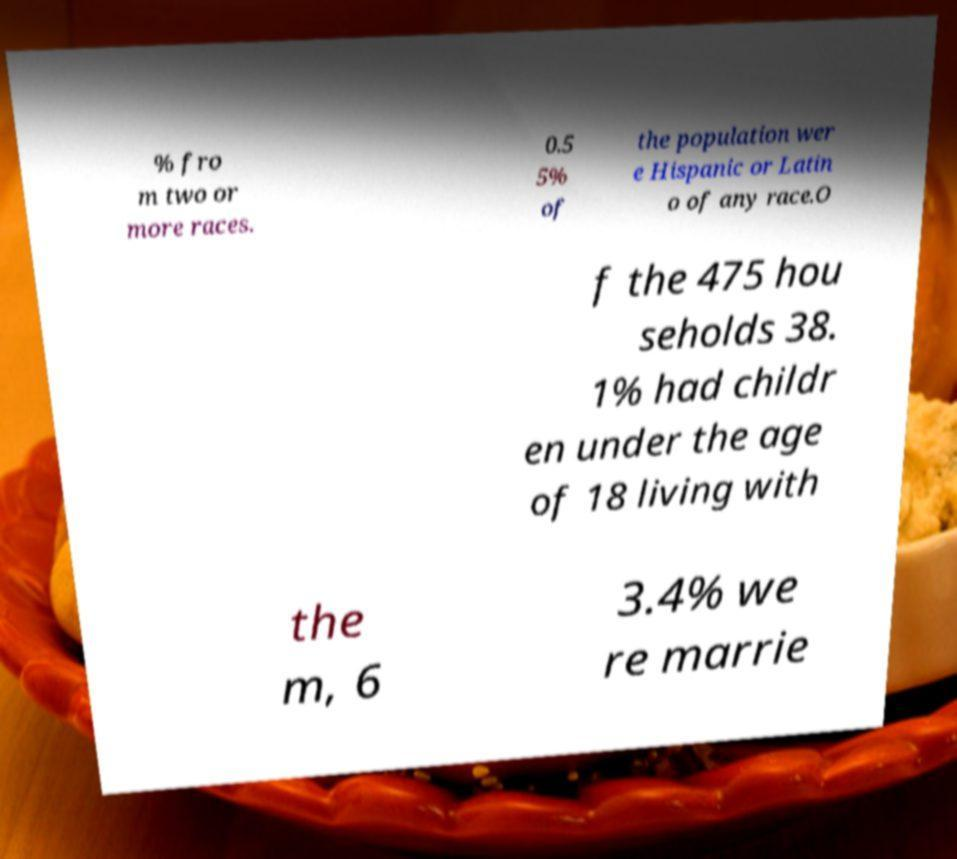Can you read and provide the text displayed in the image?This photo seems to have some interesting text. Can you extract and type it out for me? % fro m two or more races. 0.5 5% of the population wer e Hispanic or Latin o of any race.O f the 475 hou seholds 38. 1% had childr en under the age of 18 living with the m, 6 3.4% we re marrie 